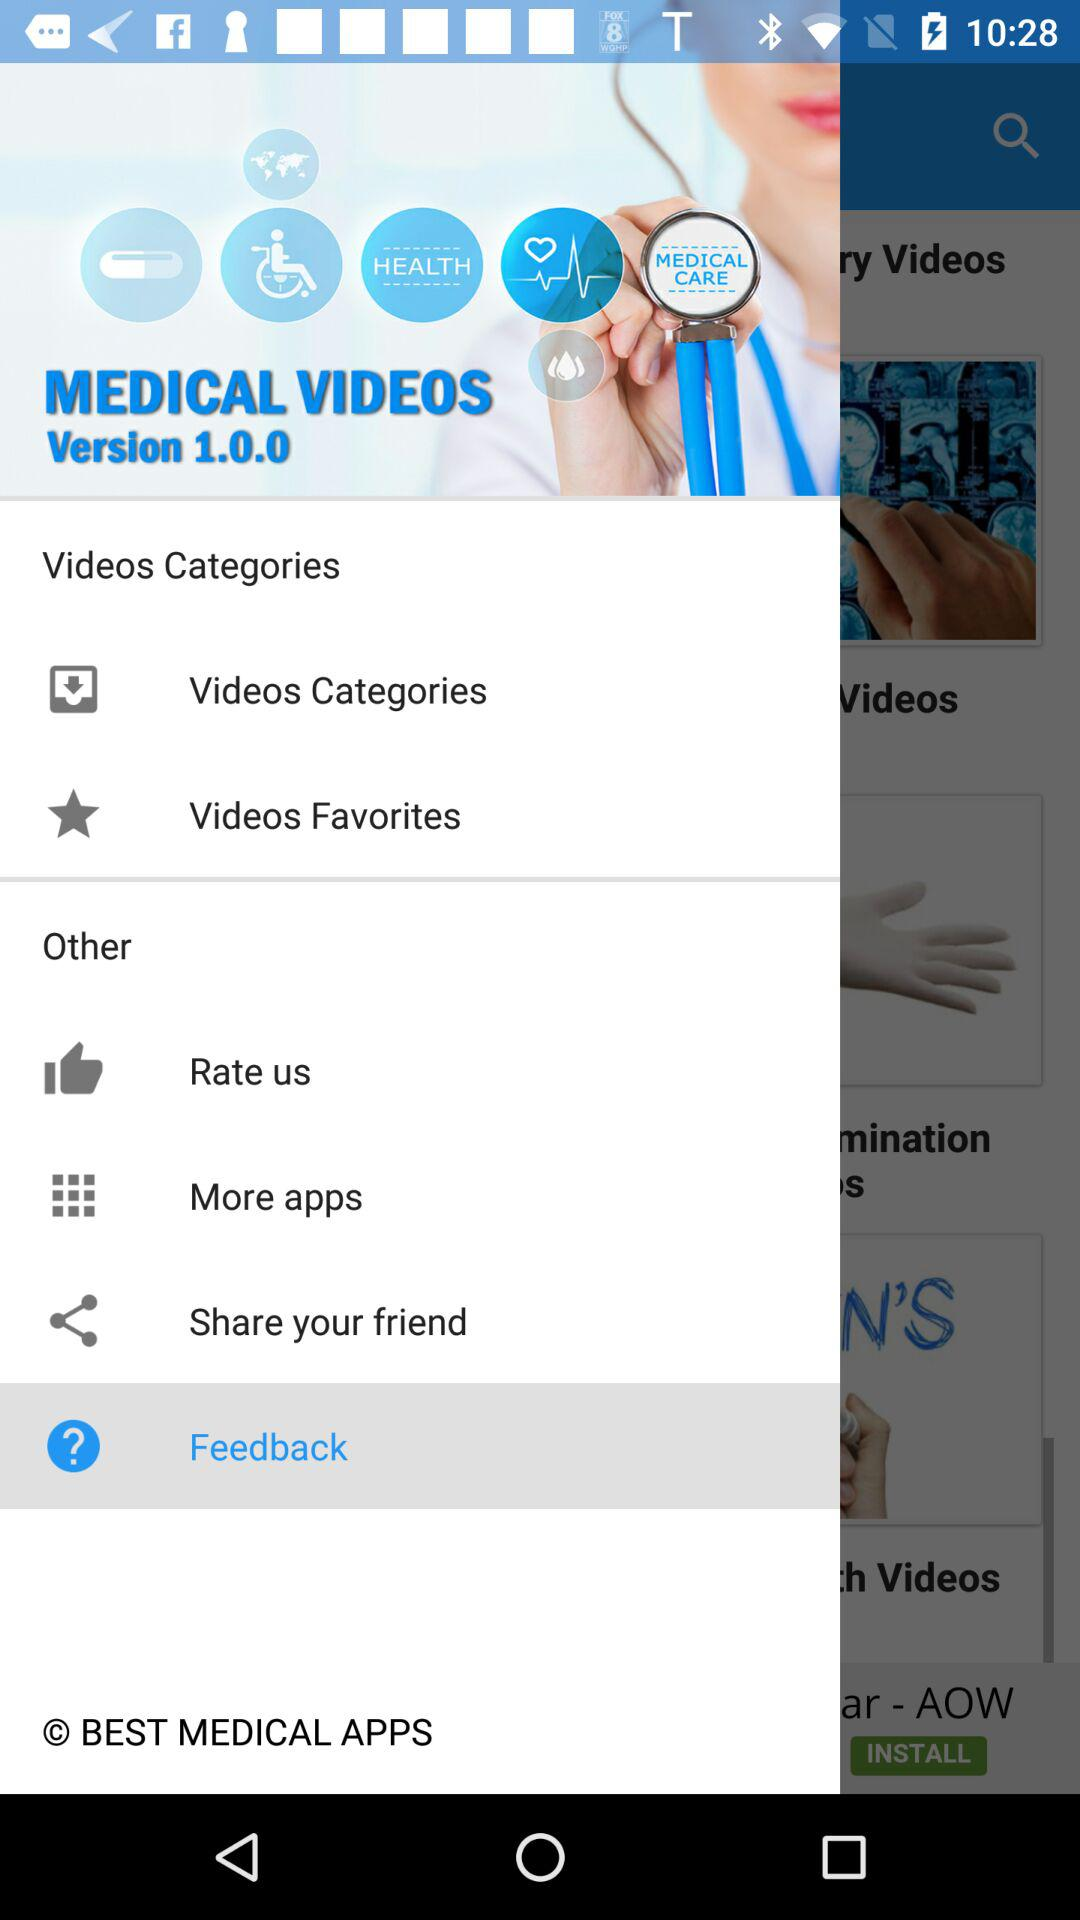What is the version? The version is 1.0.0. 